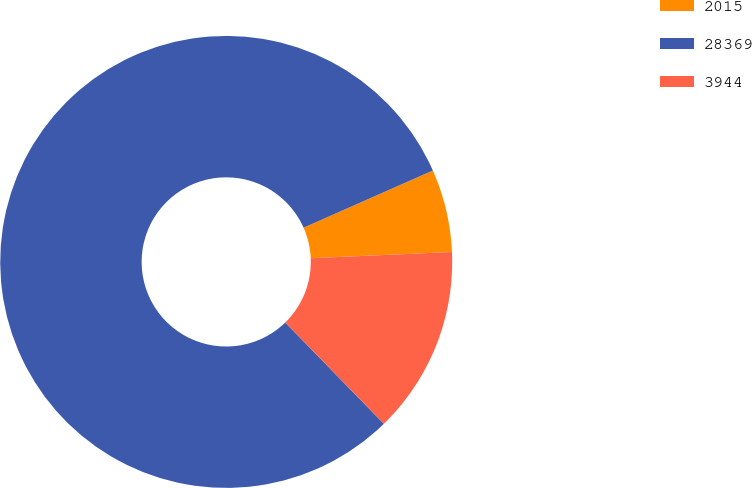Convert chart to OTSL. <chart><loc_0><loc_0><loc_500><loc_500><pie_chart><fcel>2015<fcel>28369<fcel>3944<nl><fcel>5.93%<fcel>80.66%<fcel>13.41%<nl></chart> 